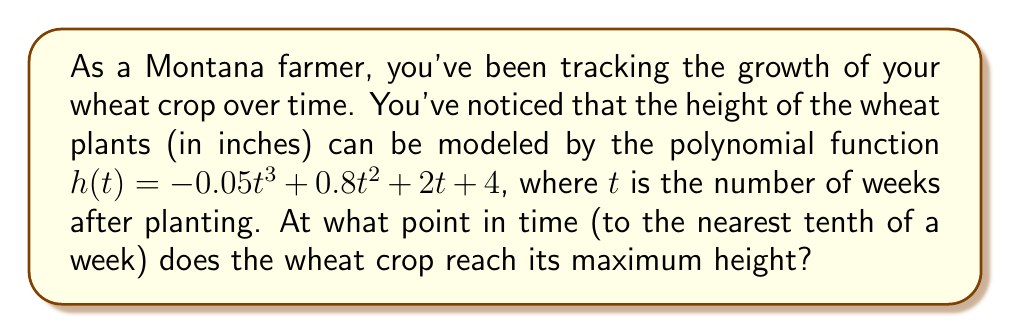Solve this math problem. To find the maximum height of the wheat crop, we need to follow these steps:

1) The maximum height occurs at the point where the rate of change (derivative) of the height function is zero. Let's find the derivative of $h(t)$:

   $h'(t) = -0.15t^2 + 1.6t + 2$

2) Set the derivative equal to zero and solve for $t$:

   $-0.15t^2 + 1.6t + 2 = 0$

3) This is a quadratic equation. We can solve it using the quadratic formula:
   $t = \frac{-b \pm \sqrt{b^2 - 4ac}}{2a}$

   Where $a = -0.15$, $b = 1.6$, and $c = 2$

4) Plugging these values into the quadratic formula:

   $t = \frac{-1.6 \pm \sqrt{1.6^2 - 4(-0.15)(2)}}{2(-0.15)}$

5) Simplifying:

   $t = \frac{-1.6 \pm \sqrt{2.56 + 1.2}}{-0.3} = \frac{-1.6 \pm \sqrt{3.76}}{-0.3} = \frac{-1.6 \pm 1.939}{-0.3}$

6) This gives us two solutions:

   $t_1 = \frac{-1.6 + 1.939}{-0.3} \approx 1.13$
   $t_2 = \frac{-1.6 - 1.939}{-0.3} \approx 11.80$

7) Since we're looking for the maximum height, and the leading coefficient of our original function is negative (indicating the function opens downward), the later critical point (11.80) will be our maximum.

8) Rounding to the nearest tenth of a week:

   $11.80 \approx 11.8$ weeks

Therefore, the wheat crop reaches its maximum height approximately 11.8 weeks after planting.
Answer: 11.8 weeks 